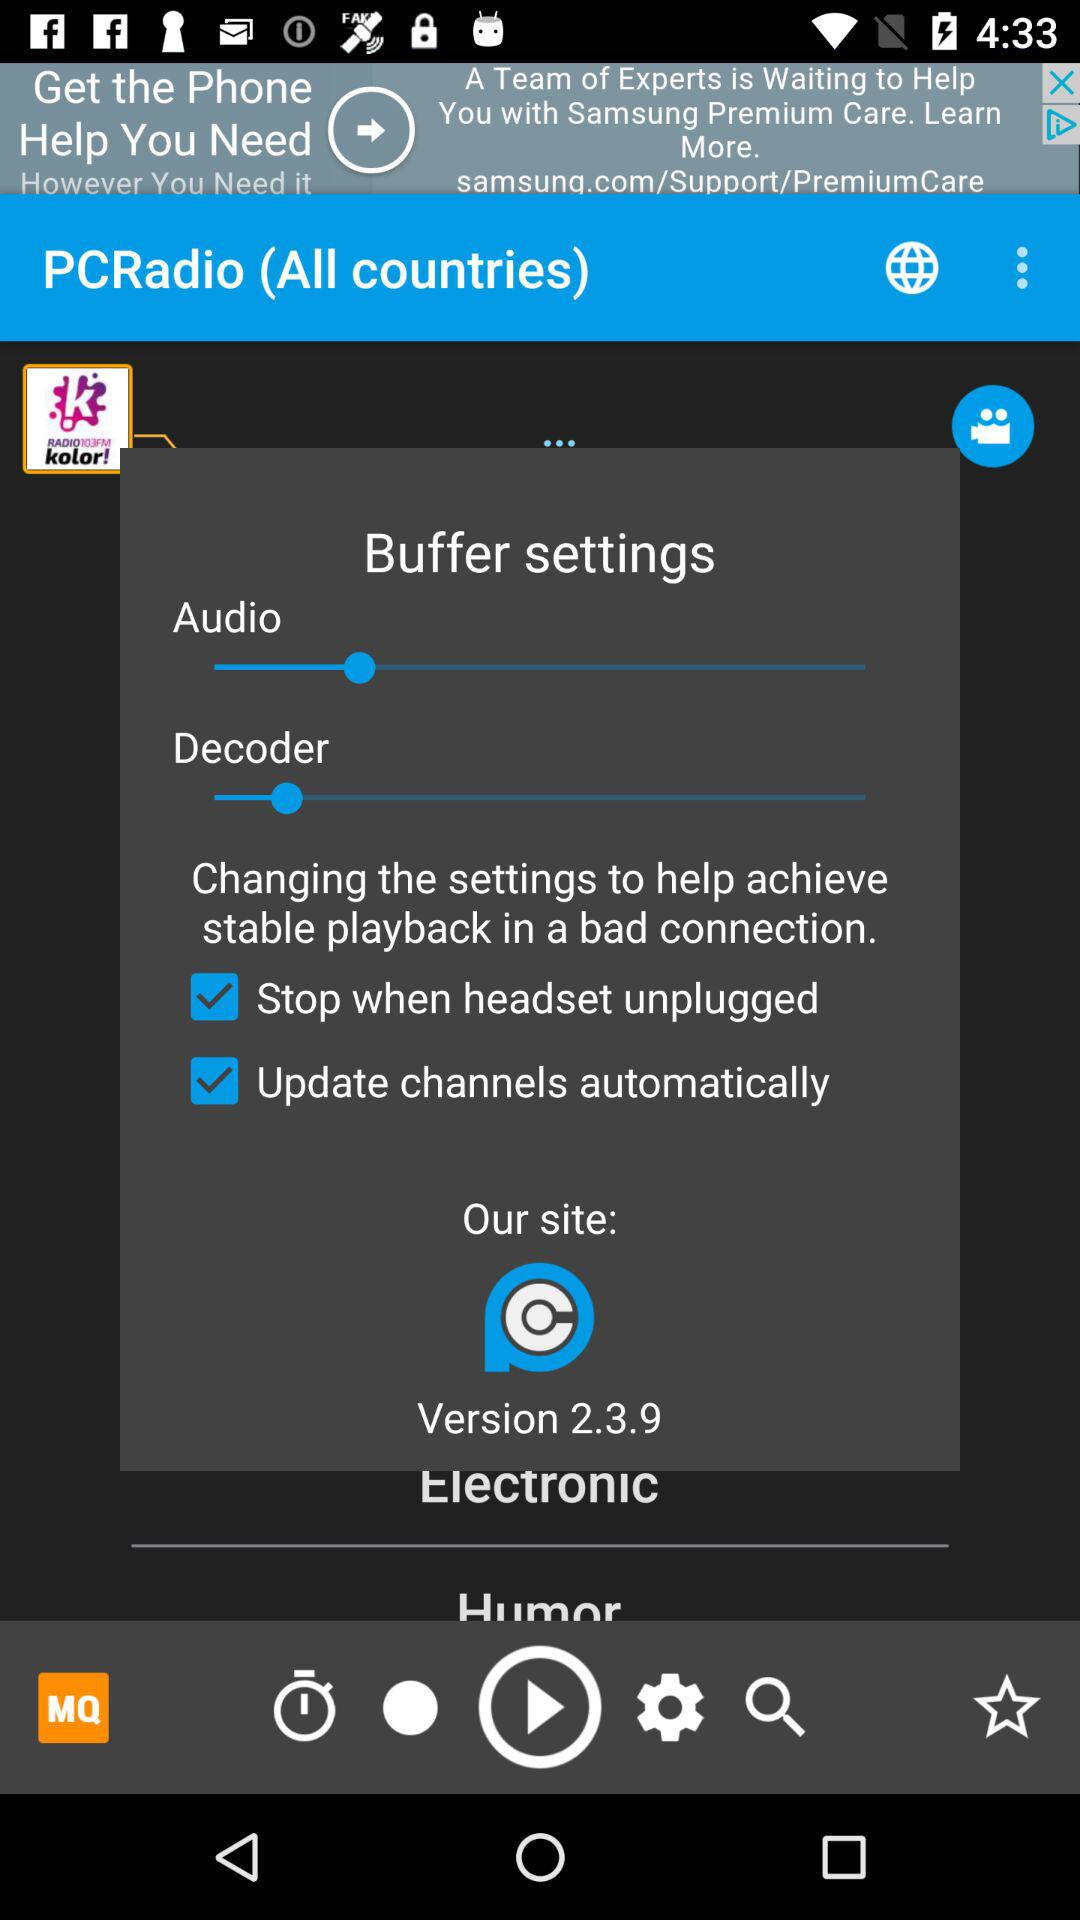What is the version of the application? The version is 2.3.9. 